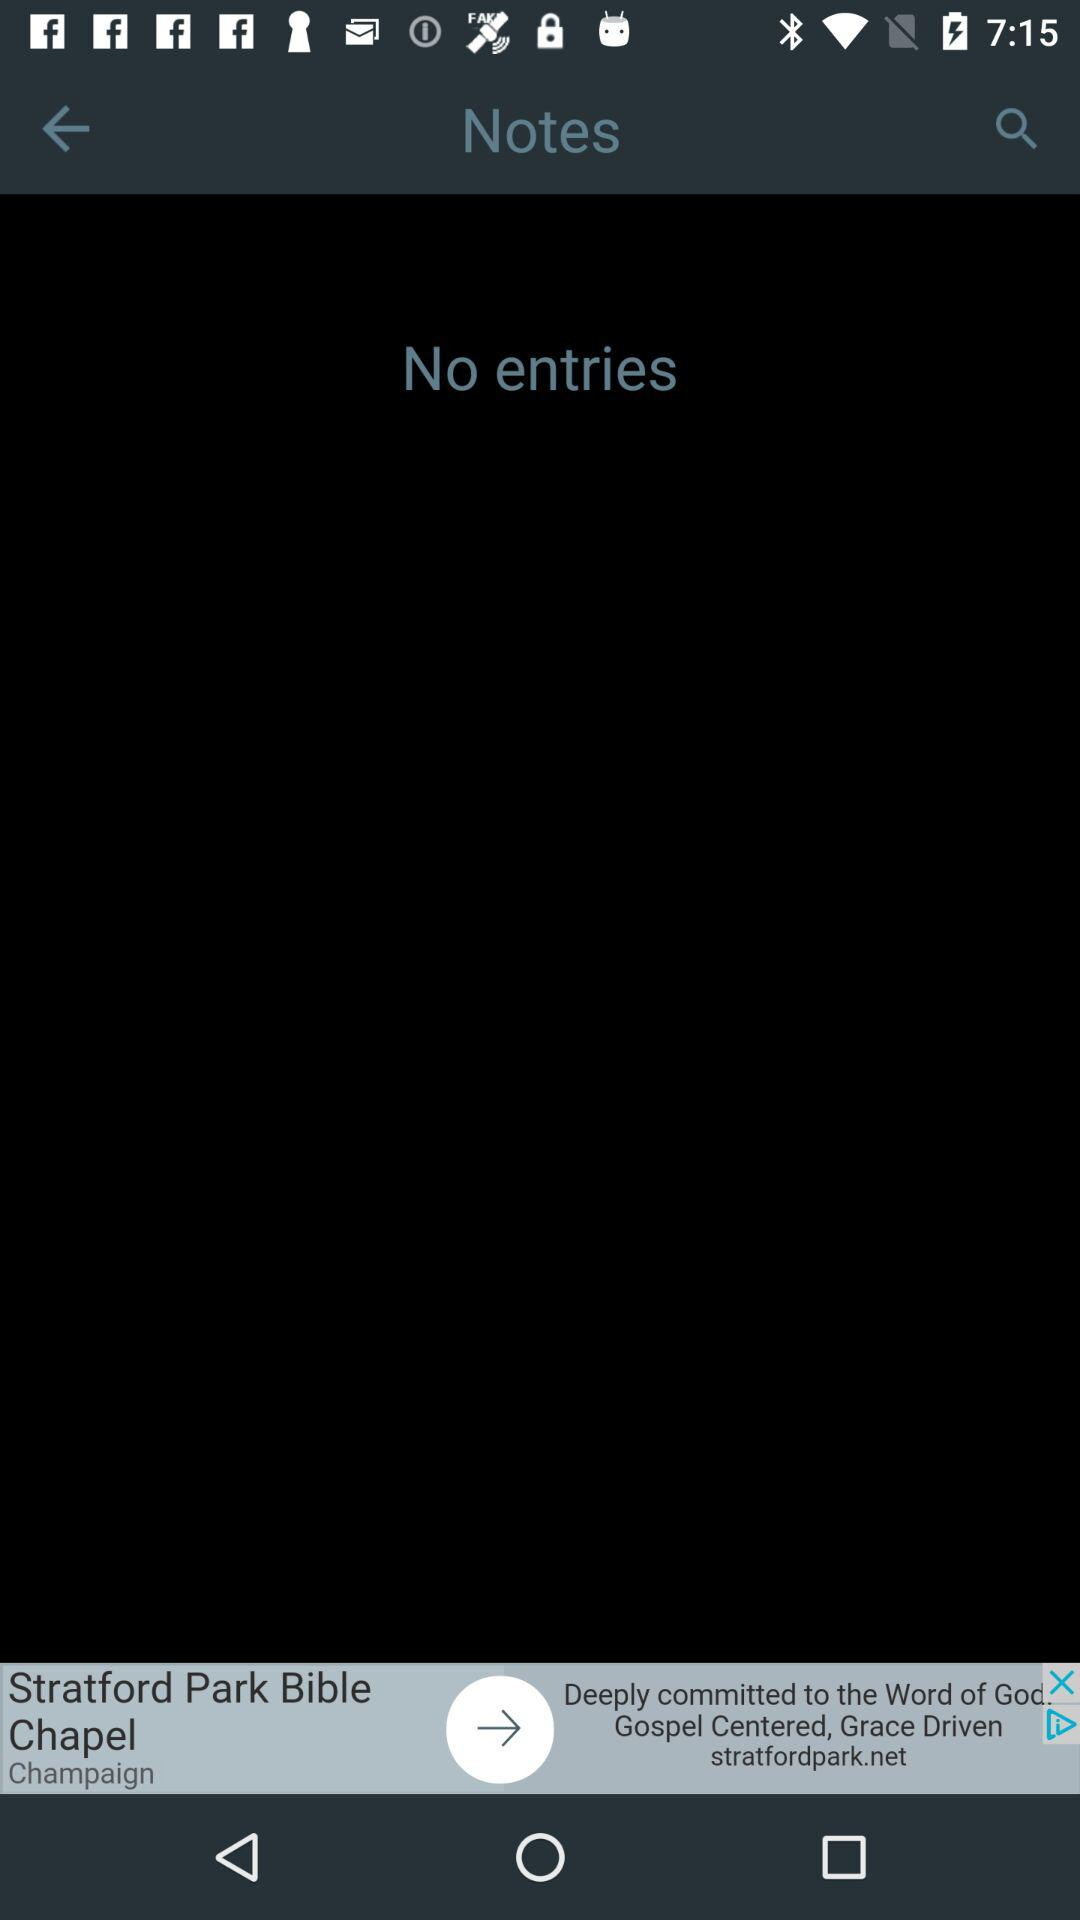How many notes was there?
When the provided information is insufficient, respond with <no answer>. <no answer> 